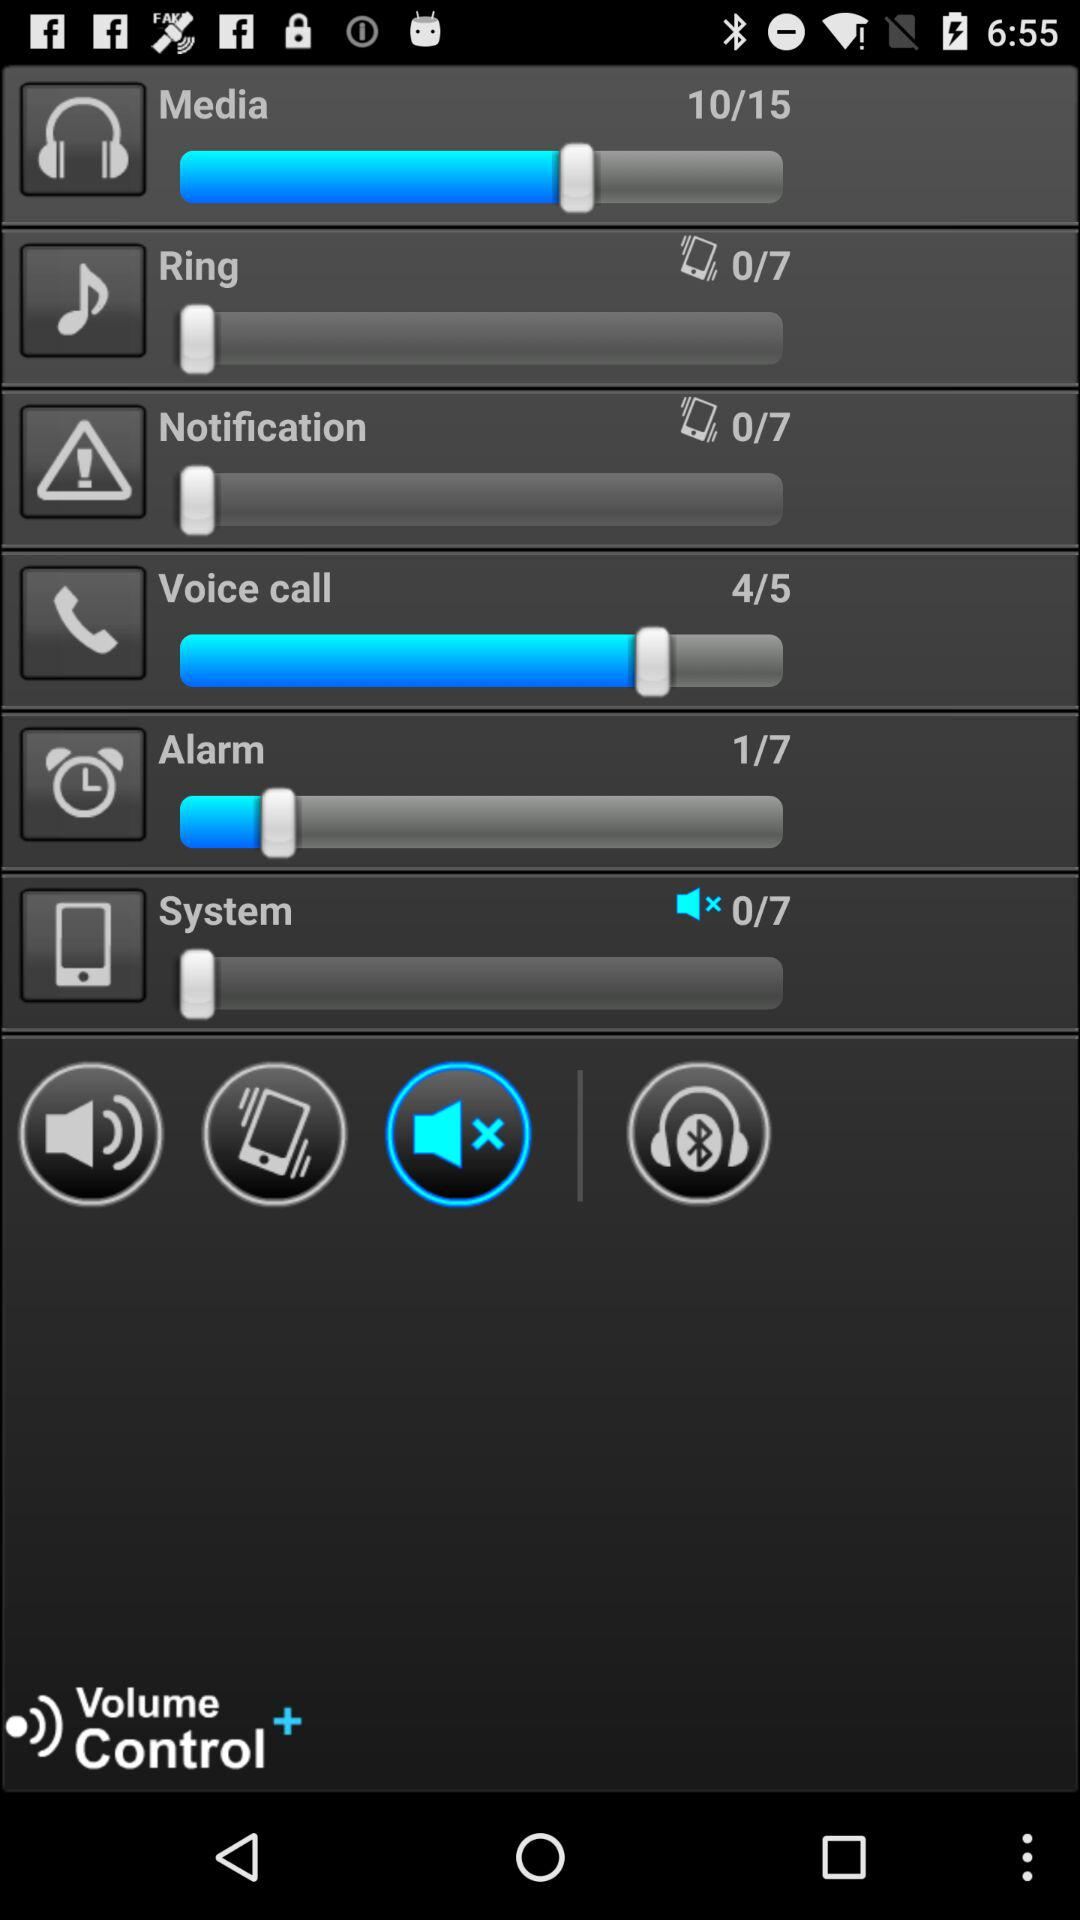What is the total number of alarm?
When the provided information is insufficient, respond with <no answer>. <no answer> 